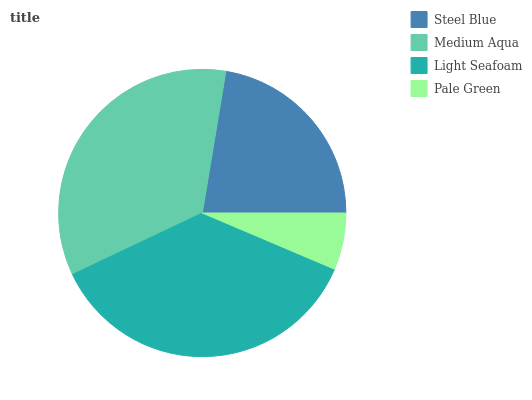Is Pale Green the minimum?
Answer yes or no. Yes. Is Light Seafoam the maximum?
Answer yes or no. Yes. Is Medium Aqua the minimum?
Answer yes or no. No. Is Medium Aqua the maximum?
Answer yes or no. No. Is Medium Aqua greater than Steel Blue?
Answer yes or no. Yes. Is Steel Blue less than Medium Aqua?
Answer yes or no. Yes. Is Steel Blue greater than Medium Aqua?
Answer yes or no. No. Is Medium Aqua less than Steel Blue?
Answer yes or no. No. Is Medium Aqua the high median?
Answer yes or no. Yes. Is Steel Blue the low median?
Answer yes or no. Yes. Is Steel Blue the high median?
Answer yes or no. No. Is Light Seafoam the low median?
Answer yes or no. No. 